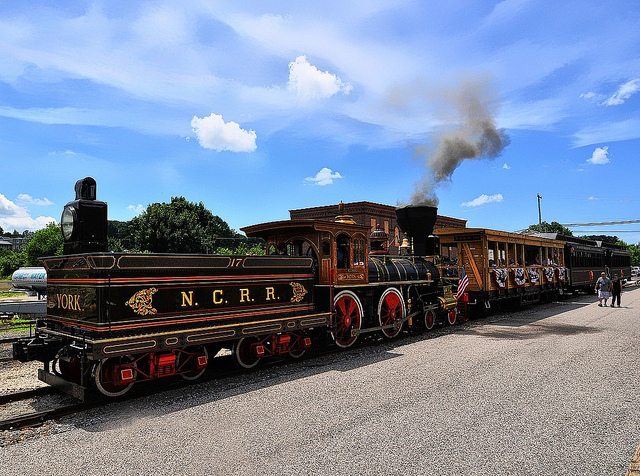Extract all visible text content from this image. 017 YORK. N C R R 